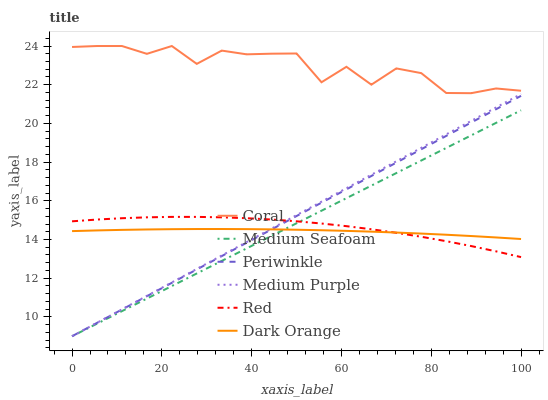Does Dark Orange have the minimum area under the curve?
Answer yes or no. Yes. Does Coral have the maximum area under the curve?
Answer yes or no. Yes. Does Medium Purple have the minimum area under the curve?
Answer yes or no. No. Does Medium Purple have the maximum area under the curve?
Answer yes or no. No. Is Medium Seafoam the smoothest?
Answer yes or no. Yes. Is Coral the roughest?
Answer yes or no. Yes. Is Medium Purple the smoothest?
Answer yes or no. No. Is Medium Purple the roughest?
Answer yes or no. No. Does Medium Purple have the lowest value?
Answer yes or no. Yes. Does Coral have the lowest value?
Answer yes or no. No. Does Coral have the highest value?
Answer yes or no. Yes. Does Medium Purple have the highest value?
Answer yes or no. No. Is Red less than Coral?
Answer yes or no. Yes. Is Coral greater than Dark Orange?
Answer yes or no. Yes. Does Red intersect Medium Purple?
Answer yes or no. Yes. Is Red less than Medium Purple?
Answer yes or no. No. Is Red greater than Medium Purple?
Answer yes or no. No. Does Red intersect Coral?
Answer yes or no. No. 